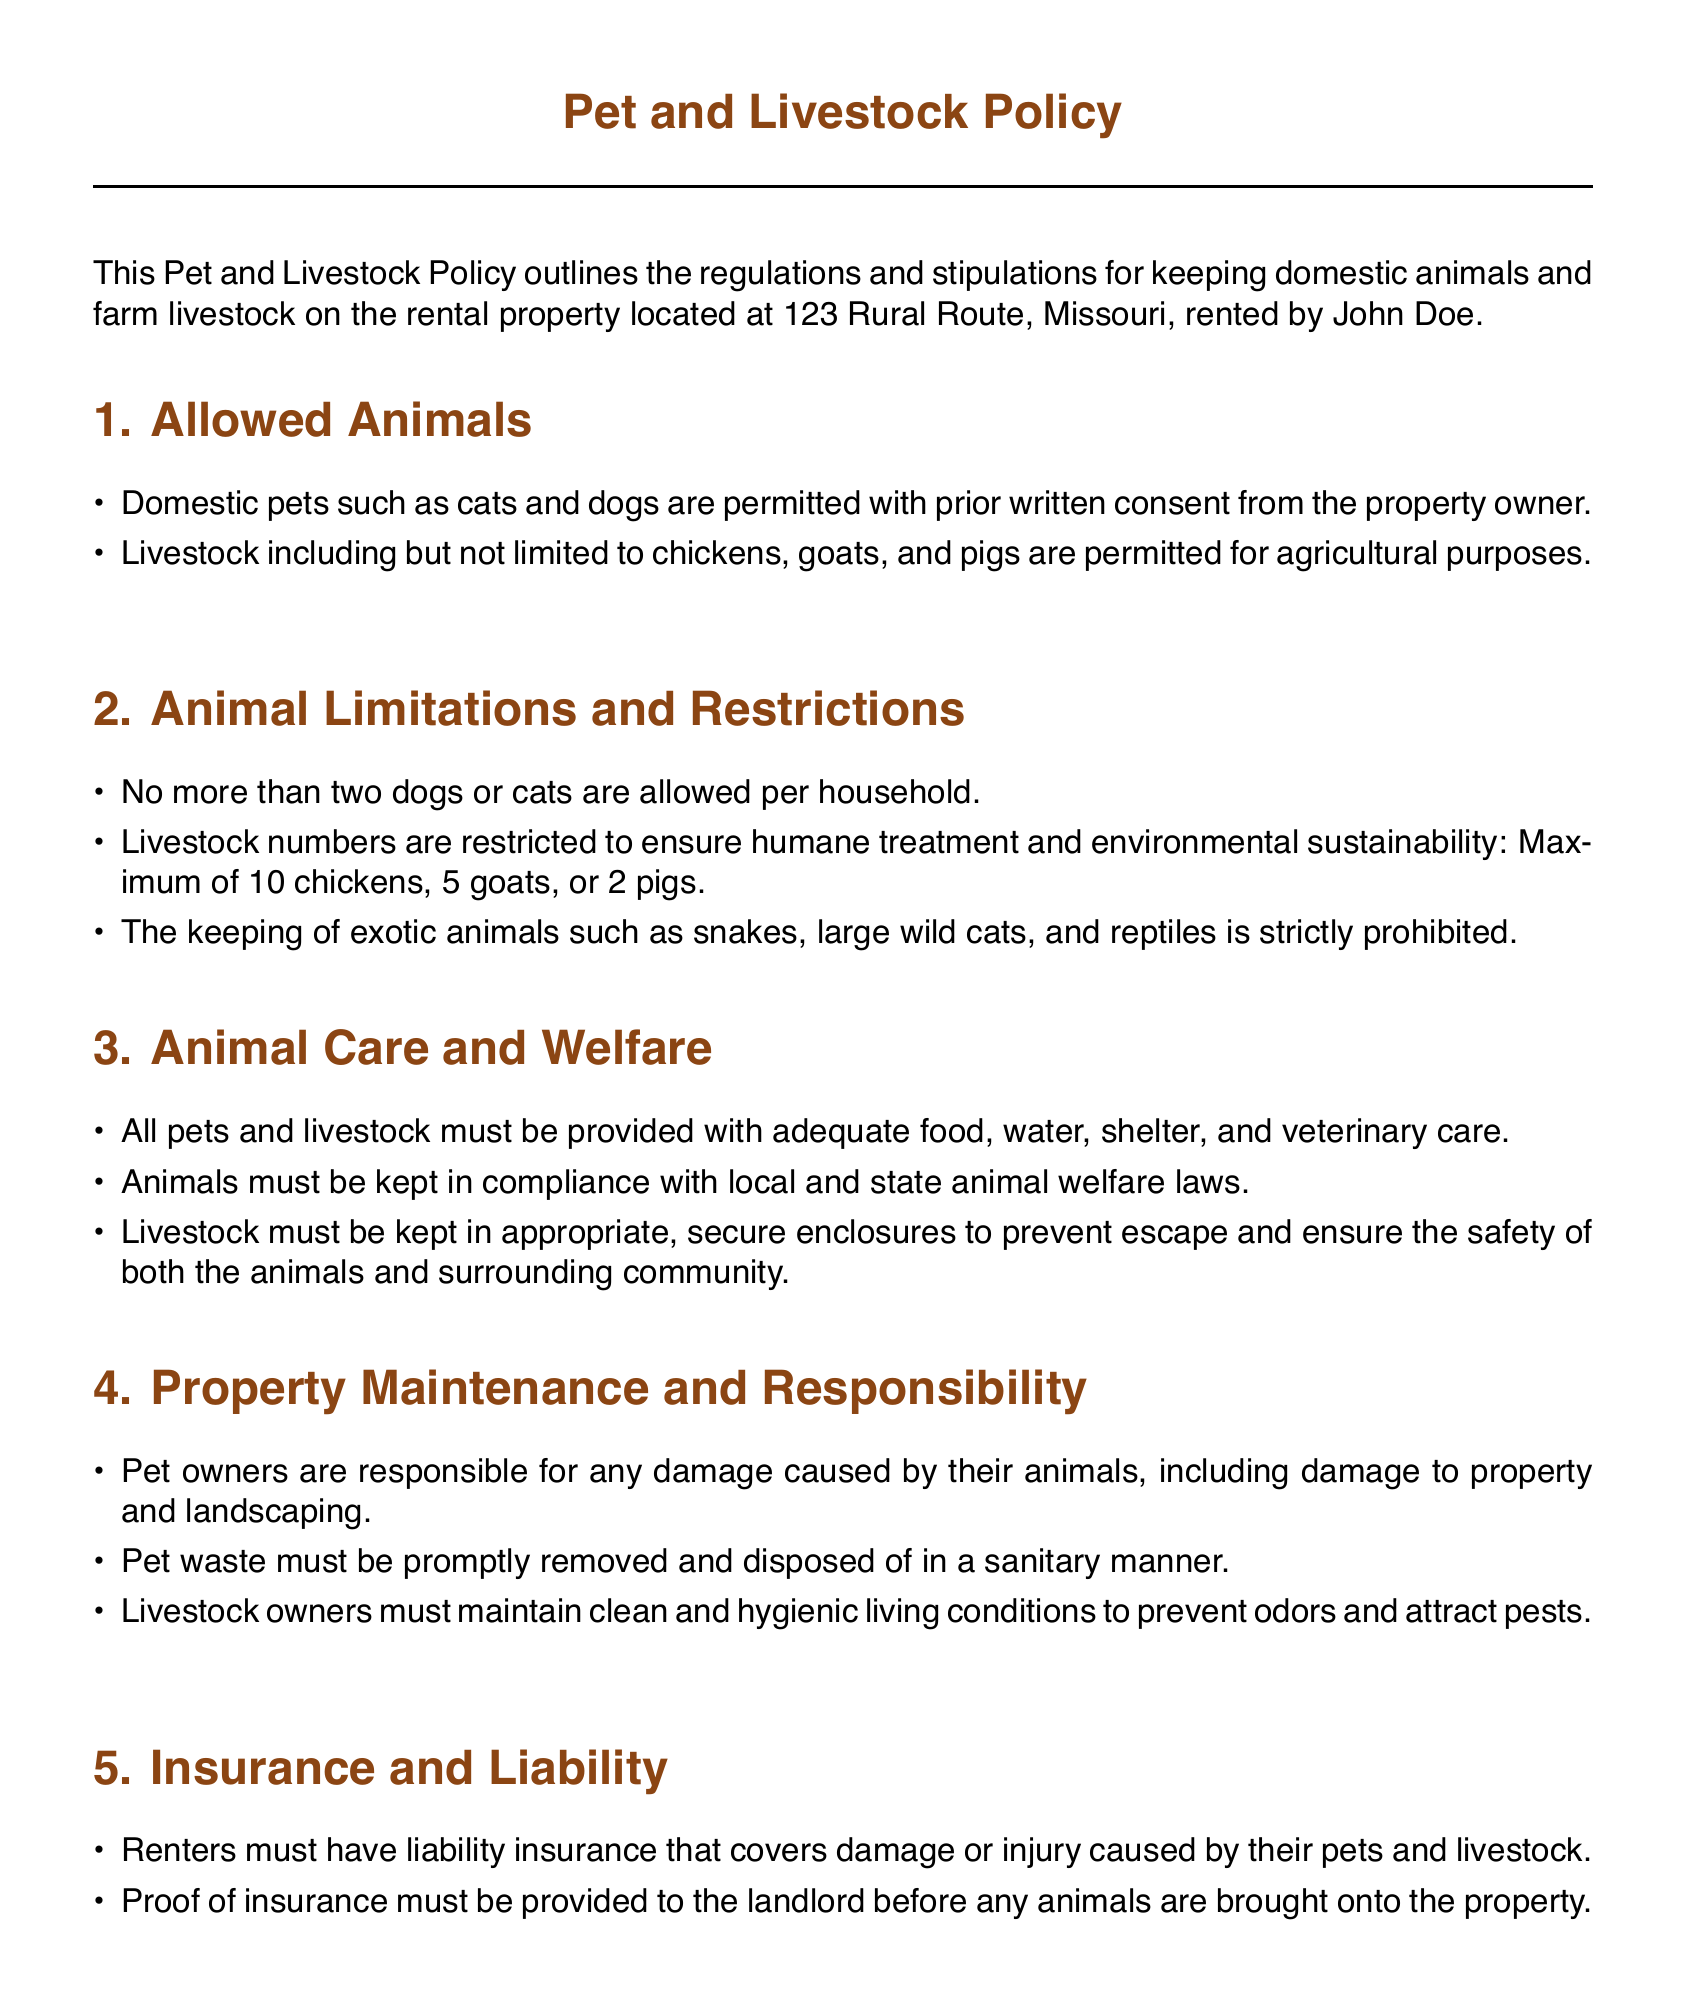What types of domestic pets are allowed? The policy states that domestic pets such as cats and dogs are permitted with prior written consent from the property owner.
Answer: Cats and dogs What is the maximum number of cats allowed? The policy specifies that no more than two dogs or cats are allowed per household.
Answer: Two How many chickens can the tenant keep on the property? The document outlines that the maximum of 10 chickens is permitted for keeping on the rental property.
Answer: 10 What must be provided for the care of pets and livestock? The policy requires that all pets and livestock must be provided with adequate food, water, shelter, and veterinary care.
Answer: Food, water, shelter, and veterinary care What is required before bringing animals onto the property? The document indicates that proof of insurance must be provided to the landlord before any animals are brought onto the property.
Answer: Proof of insurance What is the consequence of non-compliance with the terms? The policy states that non-compliance with any of the terms outlined may result in the removal of the animals or termination of the lease agreement.
Answer: Removal of animals or termination Who is responsible for damage caused by pets? The document specifies that pet owners are responsible for any damage caused by their animals, including damage to property and landscaping.
Answer: Pet owners How much notice is required for property inspection? The policy indicates that the property owner reserves the right to inspect the premises with 24-hour notice.
Answer: 24-hour notice 